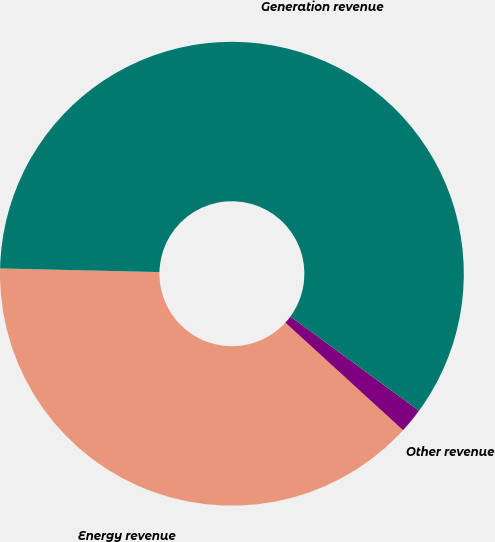Convert chart to OTSL. <chart><loc_0><loc_0><loc_500><loc_500><pie_chart><fcel>Energy revenue<fcel>Other revenue<fcel>Generation revenue<nl><fcel>38.57%<fcel>1.73%<fcel>59.69%<nl></chart> 